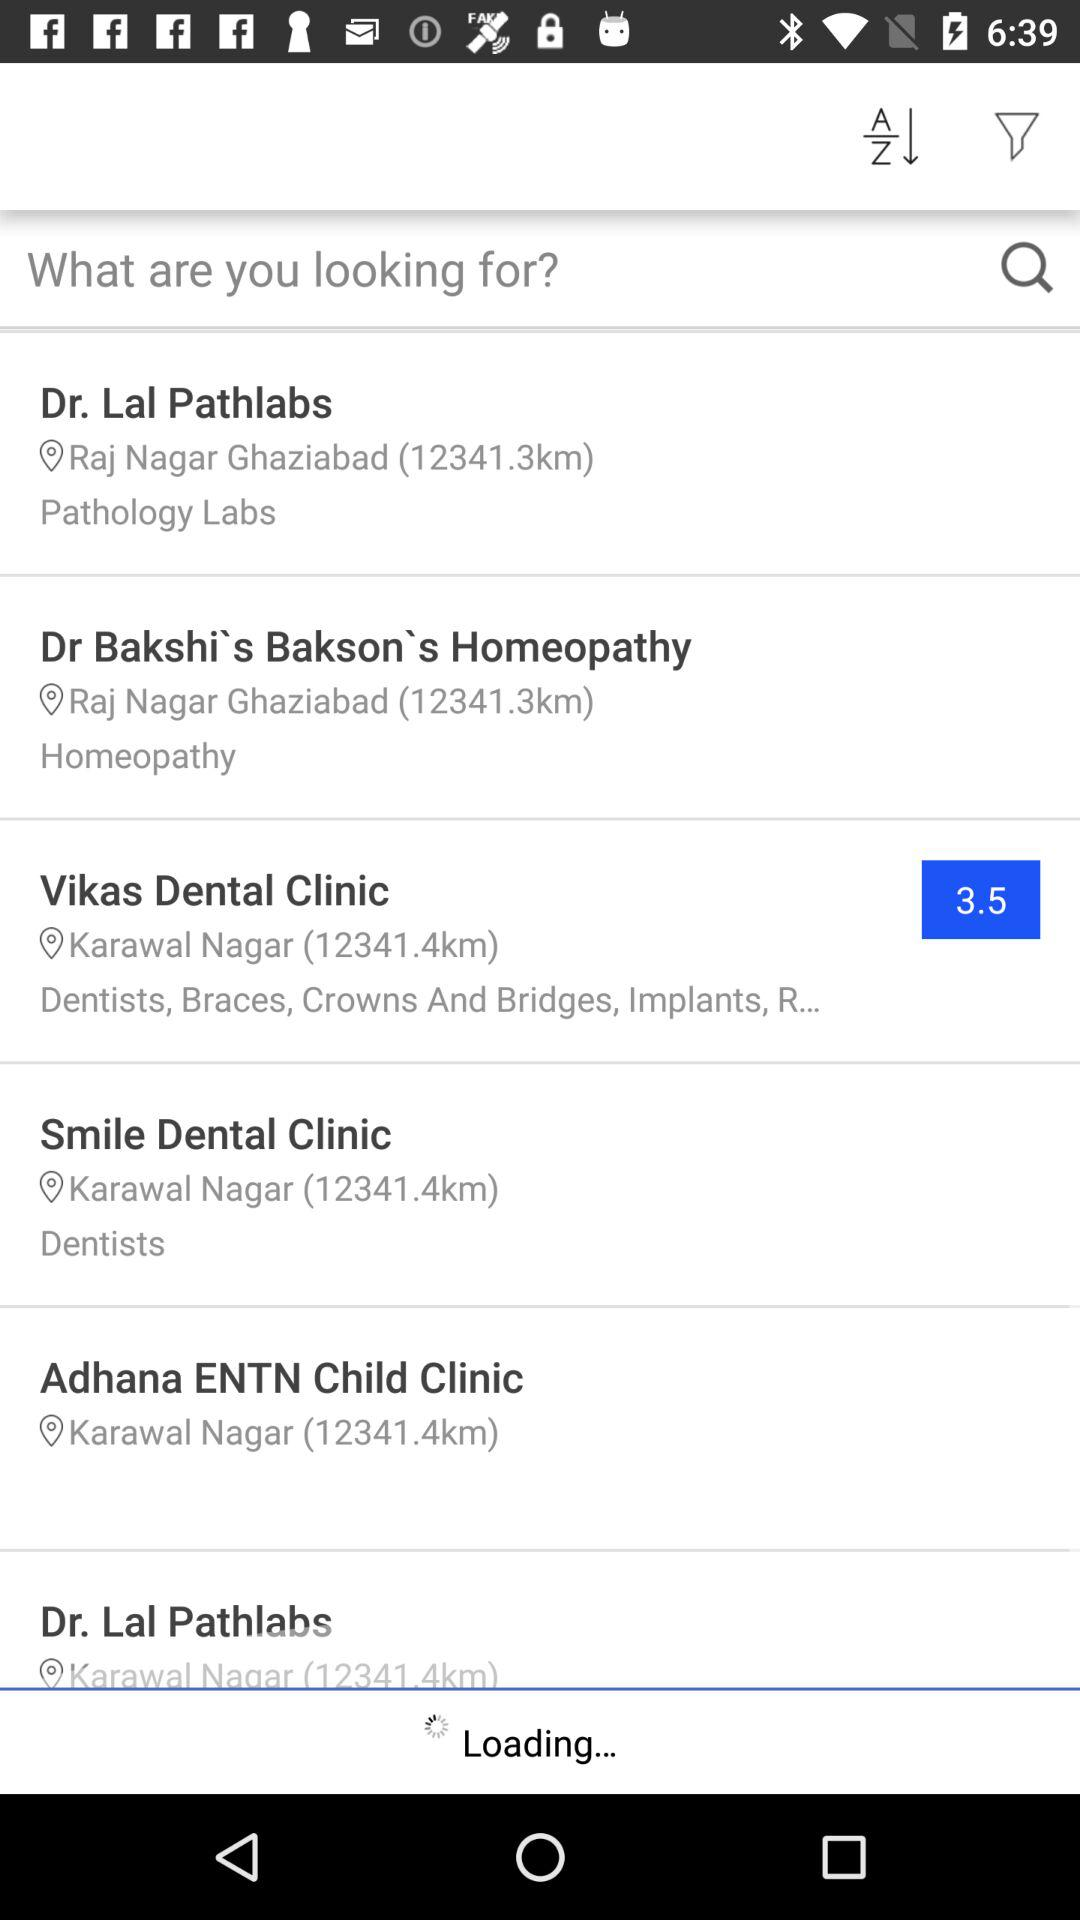What is the address of "Dr. Lal Pathlabs"? The address of "Dr. Lal Pathlabs" is Raj Nagar Ghaziabad. 